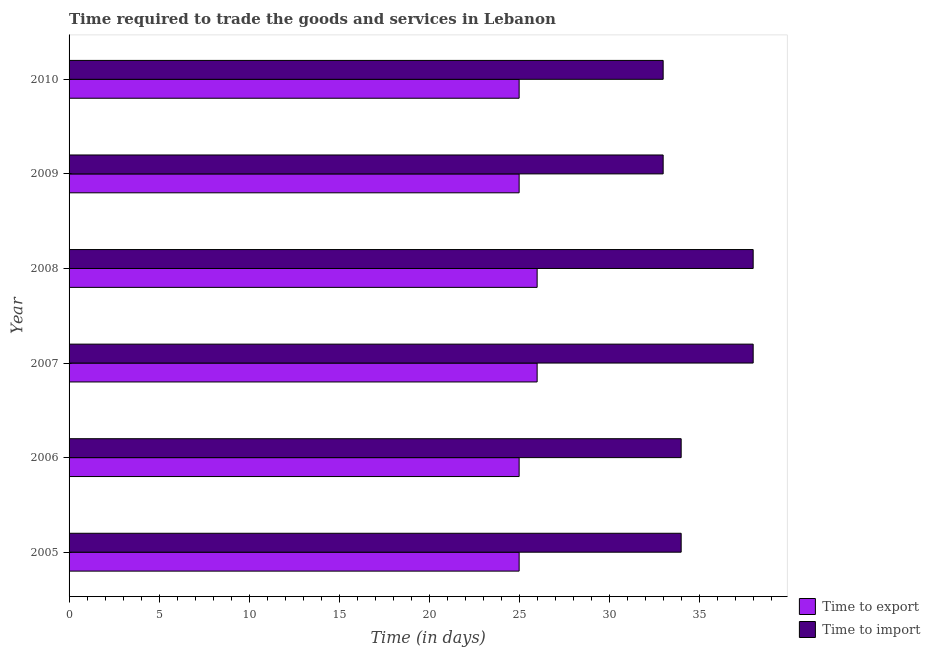Are the number of bars per tick equal to the number of legend labels?
Make the answer very short. Yes. How many bars are there on the 4th tick from the top?
Offer a terse response. 2. What is the time to import in 2009?
Give a very brief answer. 33. Across all years, what is the maximum time to export?
Give a very brief answer. 26. Across all years, what is the minimum time to import?
Make the answer very short. 33. In which year was the time to import maximum?
Your response must be concise. 2007. What is the total time to import in the graph?
Provide a succinct answer. 210. What is the difference between the time to import in 2006 and that in 2008?
Your response must be concise. -4. What is the difference between the time to export in 2008 and the time to import in 2007?
Provide a short and direct response. -12. What is the average time to export per year?
Your answer should be very brief. 25.33. In the year 2005, what is the difference between the time to export and time to import?
Make the answer very short. -9. What is the ratio of the time to import in 2006 to that in 2008?
Offer a very short reply. 0.9. Is the difference between the time to import in 2008 and 2009 greater than the difference between the time to export in 2008 and 2009?
Ensure brevity in your answer.  Yes. What is the difference between the highest and the second highest time to import?
Keep it short and to the point. 0. What is the difference between the highest and the lowest time to export?
Keep it short and to the point. 1. What does the 2nd bar from the top in 2008 represents?
Keep it short and to the point. Time to export. What does the 2nd bar from the bottom in 2006 represents?
Give a very brief answer. Time to import. How many bars are there?
Provide a short and direct response. 12. Are all the bars in the graph horizontal?
Provide a short and direct response. Yes. How many years are there in the graph?
Provide a short and direct response. 6. What is the difference between two consecutive major ticks on the X-axis?
Give a very brief answer. 5. Are the values on the major ticks of X-axis written in scientific E-notation?
Provide a succinct answer. No. Does the graph contain grids?
Your answer should be compact. No. Where does the legend appear in the graph?
Offer a very short reply. Bottom right. How are the legend labels stacked?
Make the answer very short. Vertical. What is the title of the graph?
Offer a terse response. Time required to trade the goods and services in Lebanon. Does "Register a property" appear as one of the legend labels in the graph?
Your answer should be very brief. No. What is the label or title of the X-axis?
Keep it short and to the point. Time (in days). What is the Time (in days) of Time to import in 2005?
Provide a succinct answer. 34. What is the Time (in days) of Time to import in 2006?
Make the answer very short. 34. What is the Time (in days) of Time to import in 2008?
Provide a succinct answer. 38. What is the Time (in days) of Time to export in 2009?
Provide a succinct answer. 25. What is the Time (in days) of Time to import in 2009?
Your answer should be compact. 33. What is the Time (in days) in Time to export in 2010?
Offer a very short reply. 25. What is the Time (in days) of Time to import in 2010?
Make the answer very short. 33. Across all years, what is the minimum Time (in days) in Time to export?
Give a very brief answer. 25. Across all years, what is the minimum Time (in days) in Time to import?
Give a very brief answer. 33. What is the total Time (in days) of Time to export in the graph?
Make the answer very short. 152. What is the total Time (in days) of Time to import in the graph?
Provide a short and direct response. 210. What is the difference between the Time (in days) in Time to import in 2005 and that in 2006?
Offer a very short reply. 0. What is the difference between the Time (in days) of Time to export in 2005 and that in 2007?
Provide a succinct answer. -1. What is the difference between the Time (in days) of Time to import in 2005 and that in 2007?
Your answer should be very brief. -4. What is the difference between the Time (in days) in Time to import in 2005 and that in 2008?
Your response must be concise. -4. What is the difference between the Time (in days) in Time to export in 2005 and that in 2009?
Make the answer very short. 0. What is the difference between the Time (in days) in Time to import in 2005 and that in 2009?
Offer a very short reply. 1. What is the difference between the Time (in days) in Time to import in 2005 and that in 2010?
Give a very brief answer. 1. What is the difference between the Time (in days) in Time to import in 2006 and that in 2008?
Offer a terse response. -4. What is the difference between the Time (in days) in Time to import in 2006 and that in 2009?
Provide a short and direct response. 1. What is the difference between the Time (in days) in Time to export in 2007 and that in 2008?
Provide a succinct answer. 0. What is the difference between the Time (in days) of Time to import in 2007 and that in 2009?
Provide a succinct answer. 5. What is the difference between the Time (in days) in Time to import in 2008 and that in 2009?
Your answer should be compact. 5. What is the difference between the Time (in days) in Time to export in 2008 and that in 2010?
Provide a short and direct response. 1. What is the difference between the Time (in days) in Time to import in 2008 and that in 2010?
Give a very brief answer. 5. What is the difference between the Time (in days) in Time to import in 2009 and that in 2010?
Your answer should be compact. 0. What is the difference between the Time (in days) of Time to export in 2005 and the Time (in days) of Time to import in 2008?
Your response must be concise. -13. What is the difference between the Time (in days) of Time to export in 2005 and the Time (in days) of Time to import in 2010?
Keep it short and to the point. -8. What is the difference between the Time (in days) in Time to export in 2006 and the Time (in days) in Time to import in 2008?
Your answer should be very brief. -13. What is the difference between the Time (in days) in Time to export in 2006 and the Time (in days) in Time to import in 2009?
Make the answer very short. -8. What is the difference between the Time (in days) of Time to export in 2006 and the Time (in days) of Time to import in 2010?
Give a very brief answer. -8. What is the difference between the Time (in days) of Time to export in 2007 and the Time (in days) of Time to import in 2009?
Your answer should be very brief. -7. What is the difference between the Time (in days) of Time to export in 2008 and the Time (in days) of Time to import in 2009?
Ensure brevity in your answer.  -7. What is the average Time (in days) of Time to export per year?
Offer a terse response. 25.33. In the year 2006, what is the difference between the Time (in days) of Time to export and Time (in days) of Time to import?
Give a very brief answer. -9. In the year 2007, what is the difference between the Time (in days) of Time to export and Time (in days) of Time to import?
Your response must be concise. -12. What is the ratio of the Time (in days) of Time to export in 2005 to that in 2006?
Your response must be concise. 1. What is the ratio of the Time (in days) in Time to import in 2005 to that in 2006?
Your response must be concise. 1. What is the ratio of the Time (in days) in Time to export in 2005 to that in 2007?
Provide a succinct answer. 0.96. What is the ratio of the Time (in days) in Time to import in 2005 to that in 2007?
Provide a short and direct response. 0.89. What is the ratio of the Time (in days) in Time to export in 2005 to that in 2008?
Ensure brevity in your answer.  0.96. What is the ratio of the Time (in days) of Time to import in 2005 to that in 2008?
Offer a very short reply. 0.89. What is the ratio of the Time (in days) of Time to import in 2005 to that in 2009?
Keep it short and to the point. 1.03. What is the ratio of the Time (in days) of Time to export in 2005 to that in 2010?
Provide a succinct answer. 1. What is the ratio of the Time (in days) in Time to import in 2005 to that in 2010?
Your response must be concise. 1.03. What is the ratio of the Time (in days) in Time to export in 2006 to that in 2007?
Give a very brief answer. 0.96. What is the ratio of the Time (in days) of Time to import in 2006 to that in 2007?
Your answer should be compact. 0.89. What is the ratio of the Time (in days) in Time to export in 2006 to that in 2008?
Offer a very short reply. 0.96. What is the ratio of the Time (in days) in Time to import in 2006 to that in 2008?
Provide a succinct answer. 0.89. What is the ratio of the Time (in days) in Time to import in 2006 to that in 2009?
Your answer should be very brief. 1.03. What is the ratio of the Time (in days) of Time to import in 2006 to that in 2010?
Your response must be concise. 1.03. What is the ratio of the Time (in days) of Time to export in 2007 to that in 2008?
Provide a short and direct response. 1. What is the ratio of the Time (in days) of Time to import in 2007 to that in 2008?
Provide a short and direct response. 1. What is the ratio of the Time (in days) in Time to export in 2007 to that in 2009?
Your answer should be very brief. 1.04. What is the ratio of the Time (in days) of Time to import in 2007 to that in 2009?
Keep it short and to the point. 1.15. What is the ratio of the Time (in days) in Time to import in 2007 to that in 2010?
Your answer should be compact. 1.15. What is the ratio of the Time (in days) in Time to export in 2008 to that in 2009?
Keep it short and to the point. 1.04. What is the ratio of the Time (in days) of Time to import in 2008 to that in 2009?
Your answer should be compact. 1.15. What is the ratio of the Time (in days) in Time to import in 2008 to that in 2010?
Keep it short and to the point. 1.15. What is the ratio of the Time (in days) of Time to import in 2009 to that in 2010?
Your answer should be very brief. 1. What is the difference between the highest and the second highest Time (in days) of Time to export?
Offer a terse response. 0. What is the difference between the highest and the lowest Time (in days) of Time to export?
Your answer should be very brief. 1. What is the difference between the highest and the lowest Time (in days) in Time to import?
Provide a short and direct response. 5. 